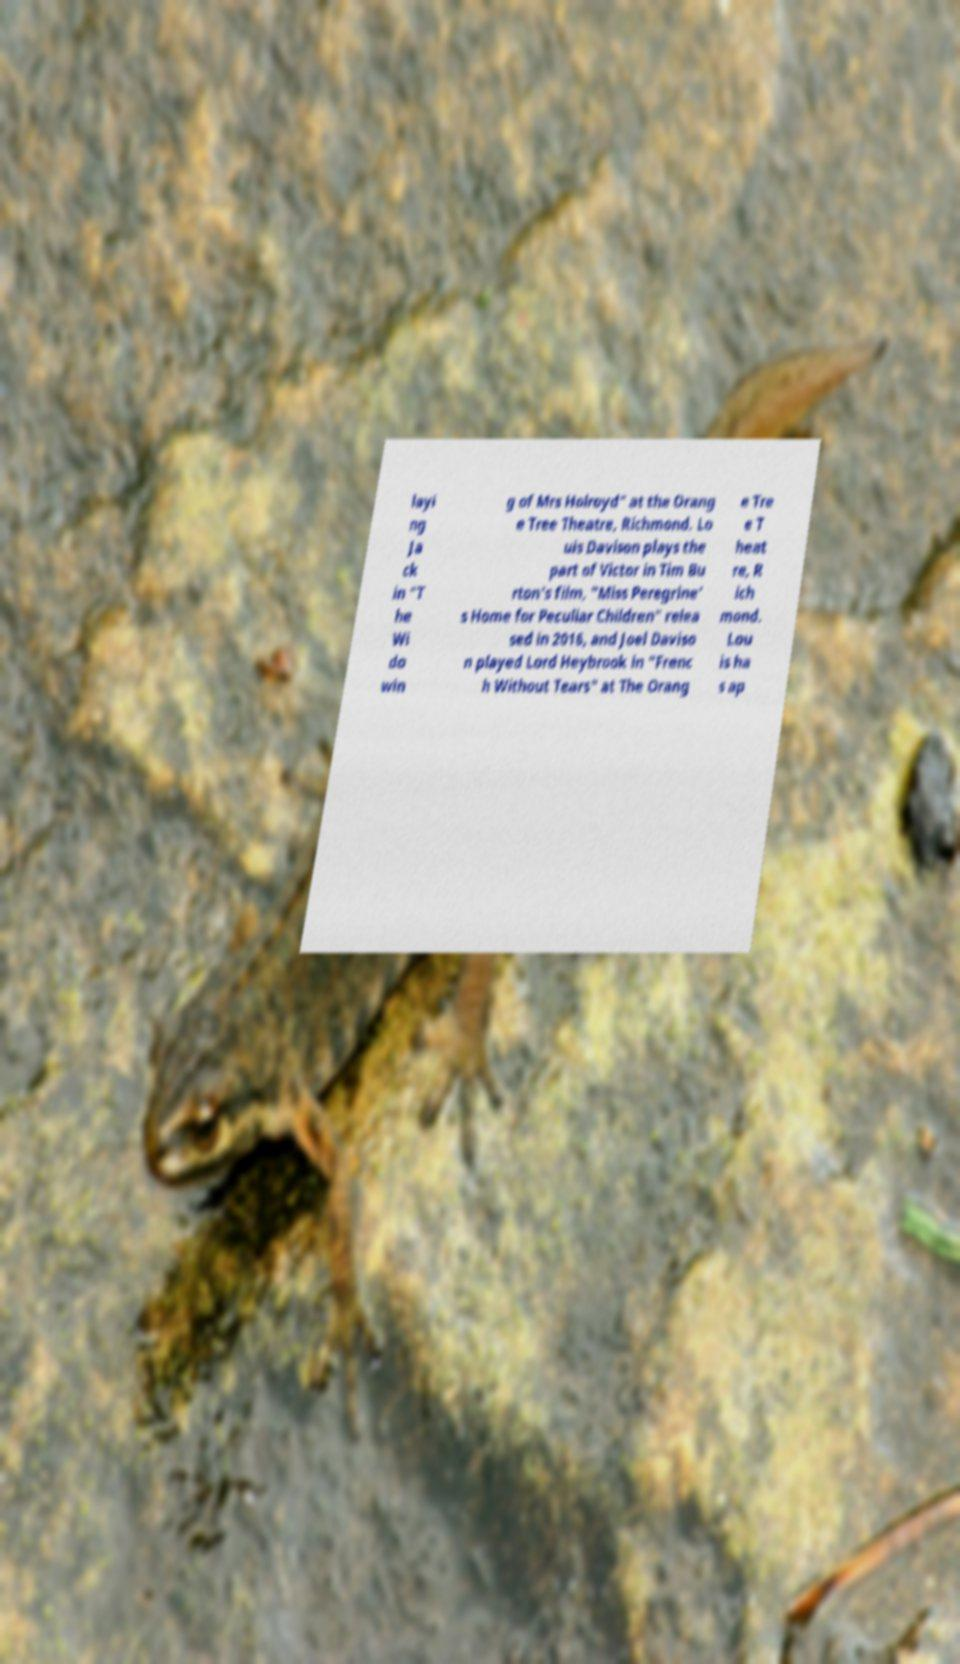I need the written content from this picture converted into text. Can you do that? layi ng Ja ck in "T he Wi do win g of Mrs Holroyd" at the Orang e Tree Theatre, Richmond. Lo uis Davison plays the part of Victor in Tim Bu rton's film, "Miss Peregrine' s Home for Peculiar Children" relea sed in 2016, and Joel Daviso n played Lord Heybrook in "Frenc h Without Tears" at The Orang e Tre e T heat re, R ich mond. Lou is ha s ap 